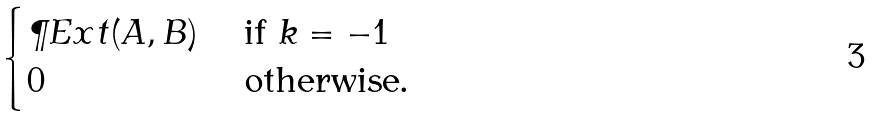Convert formula to latex. <formula><loc_0><loc_0><loc_500><loc_500>\begin{cases} \P E x t ( A , B ) & \text { if } k = - 1 \\ 0 & \text { otherwise. } \end{cases}</formula> 